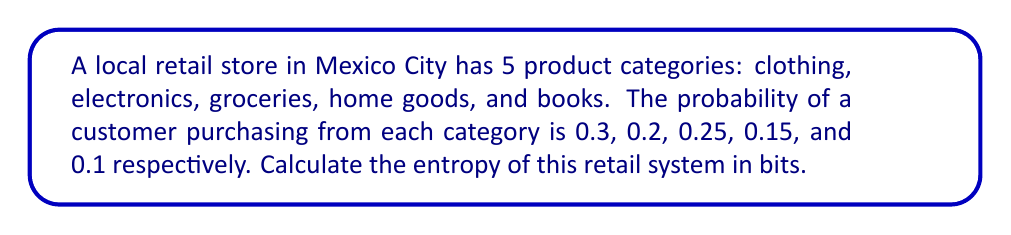Show me your answer to this math problem. To calculate the entropy of this retail system, we'll use the Shannon entropy formula:

$$ S = -\sum_{i=1}^{n} p_i \log_2(p_i) $$

Where:
- $S$ is the entropy
- $p_i$ is the probability of each outcome
- $n$ is the number of possible outcomes (in this case, 5 product categories)

Let's calculate each term:

1. Clothing: $-0.3 \log_2(0.3) = 0.521$
2. Electronics: $-0.2 \log_2(0.2) = 0.464$
3. Groceries: $-0.25 \log_2(0.25) = 0.5$
4. Home goods: $-0.15 \log_2(0.15) = 0.411$
5. Books: $-0.1 \log_2(0.1) = 0.332$

Now, sum all these terms:

$$ S = 0.521 + 0.464 + 0.5 + 0.411 + 0.332 = 2.228 $$

Therefore, the entropy of this retail system is approximately 2.228 bits.
Answer: 2.228 bits 